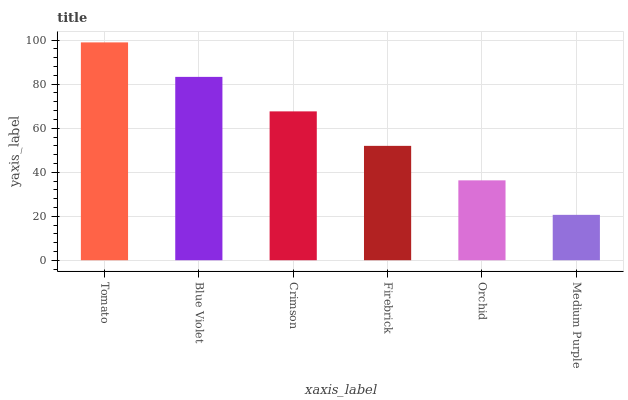Is Medium Purple the minimum?
Answer yes or no. Yes. Is Tomato the maximum?
Answer yes or no. Yes. Is Blue Violet the minimum?
Answer yes or no. No. Is Blue Violet the maximum?
Answer yes or no. No. Is Tomato greater than Blue Violet?
Answer yes or no. Yes. Is Blue Violet less than Tomato?
Answer yes or no. Yes. Is Blue Violet greater than Tomato?
Answer yes or no. No. Is Tomato less than Blue Violet?
Answer yes or no. No. Is Crimson the high median?
Answer yes or no. Yes. Is Firebrick the low median?
Answer yes or no. Yes. Is Firebrick the high median?
Answer yes or no. No. Is Tomato the low median?
Answer yes or no. No. 